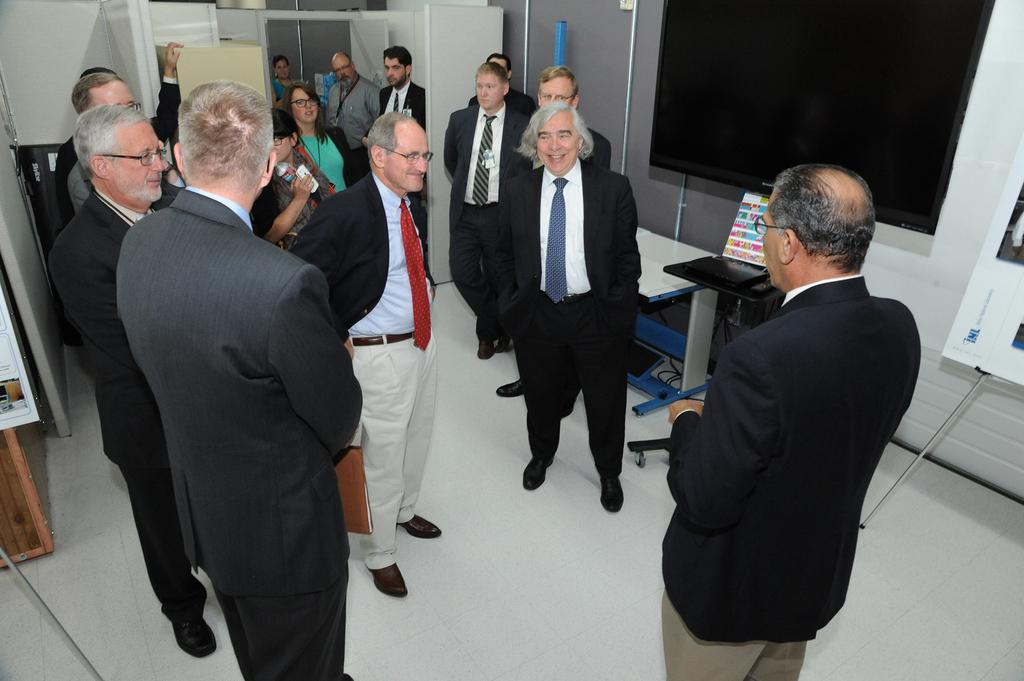How many people are in the image? There is a group of people in the image. What are the people doing in the image? The people are standing. What are the people wearing in the image? The people are wearing clothes. What is in the middle of the image? There is a table in the middle of the image. What is located in the top right of the image? There is a screen in the top right of the image. What type of juice is being served at the table in the image? There is no juice present in the image; only a group of people, their clothing, a table, and a screen are visible. 